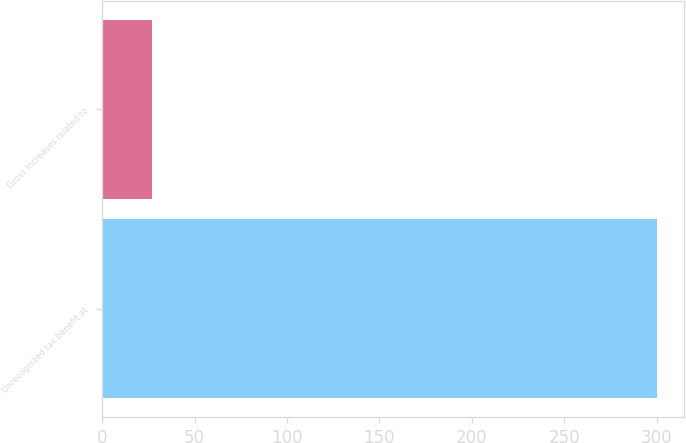Convert chart. <chart><loc_0><loc_0><loc_500><loc_500><bar_chart><fcel>Unrecognized tax benefit at<fcel>Gross increases related to<nl><fcel>300<fcel>27<nl></chart> 